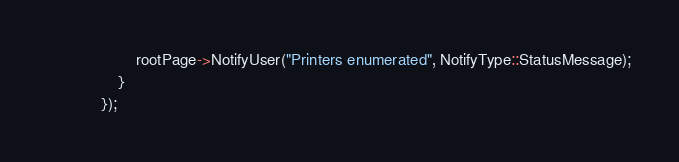Convert code to text. <code><loc_0><loc_0><loc_500><loc_500><_C++_>                    rootPage->NotifyUser("Printers enumerated", NotifyType::StatusMessage);
                }
            });</code> 